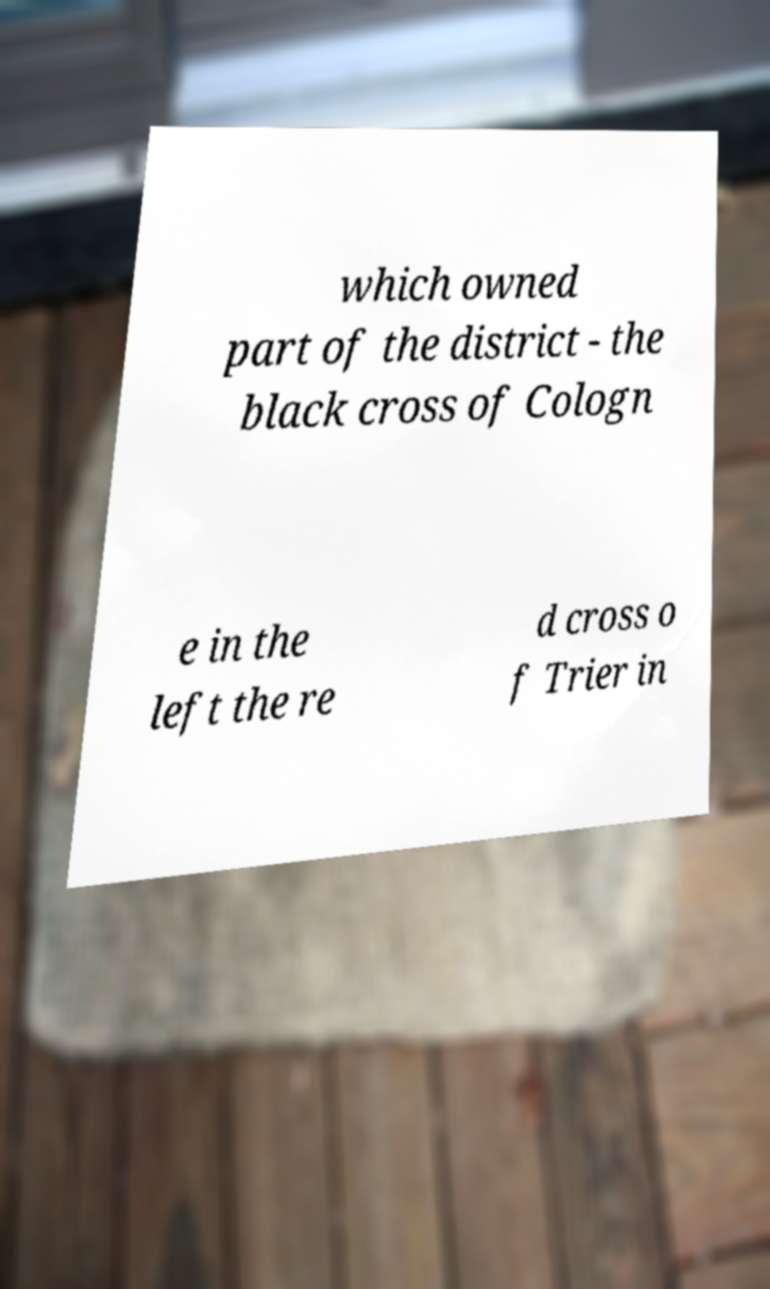I need the written content from this picture converted into text. Can you do that? which owned part of the district - the black cross of Cologn e in the left the re d cross o f Trier in 